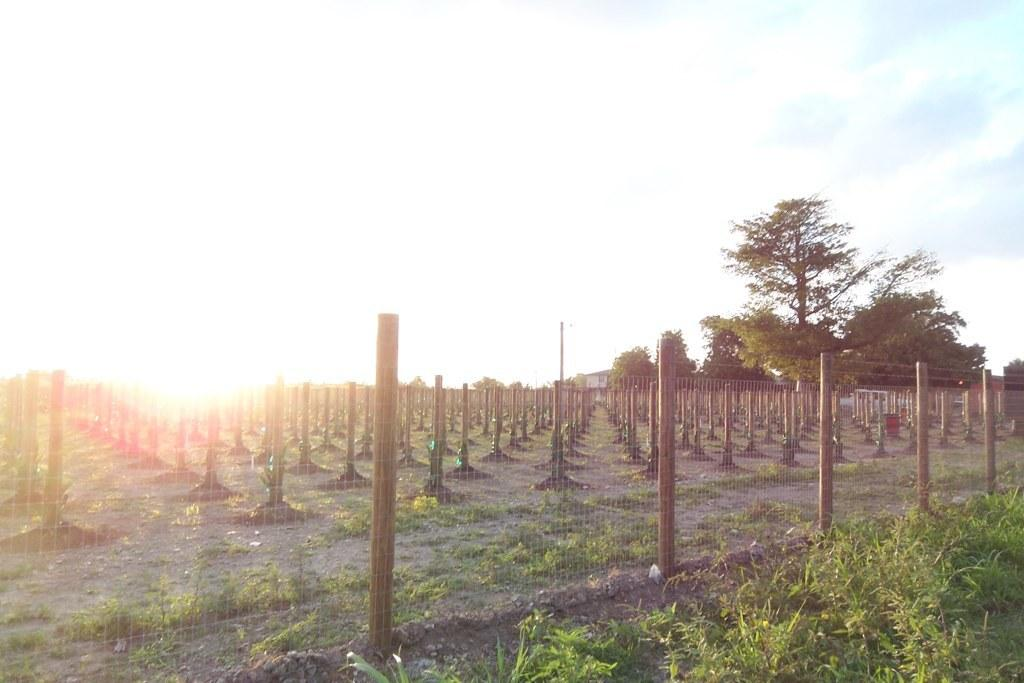What type of structures can be seen in the image? There are fences in the image. What other natural elements are present in the image? There are plants and trees in the image. What can be seen in the background of the image? The sky is visible in the background of the image. What is the condition of the sky in the image? Clouds are present in the sky. What type of sign can be seen warning about death in the image? There is no sign present in the image, nor is there any indication of a warning about death. 